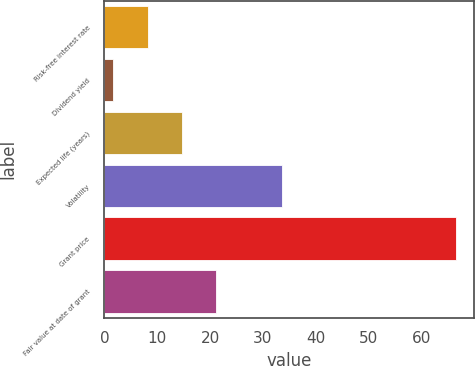<chart> <loc_0><loc_0><loc_500><loc_500><bar_chart><fcel>Risk-free interest rate<fcel>Dividend yield<fcel>Expected life (years)<fcel>Volatility<fcel>Grant price<fcel>Fair value at date of grant<nl><fcel>8.19<fcel>1.7<fcel>14.68<fcel>33.56<fcel>66.59<fcel>21.17<nl></chart> 